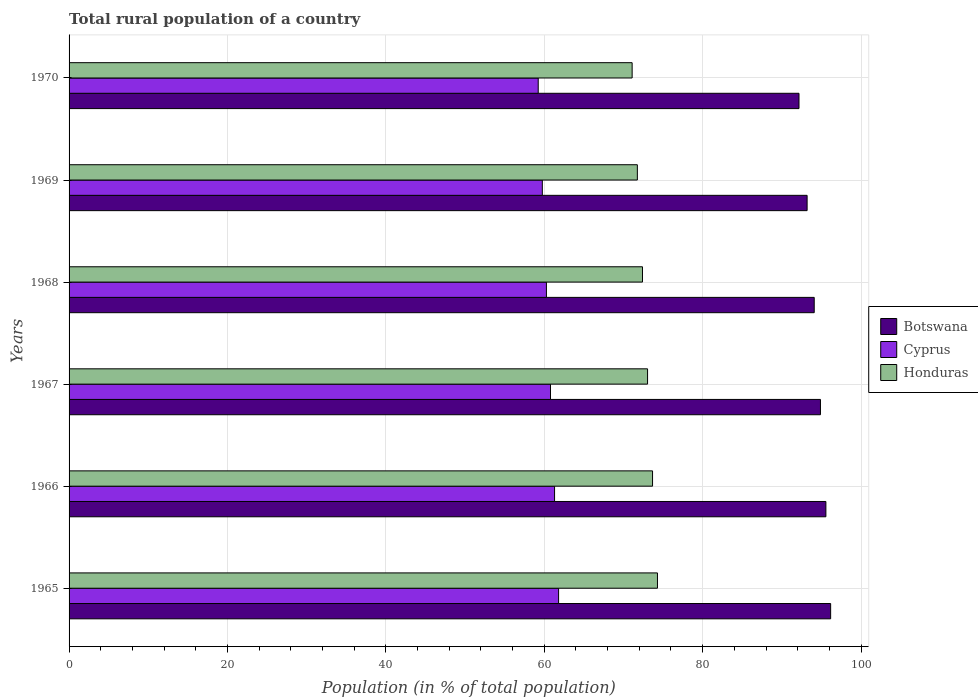How many different coloured bars are there?
Ensure brevity in your answer.  3. Are the number of bars per tick equal to the number of legend labels?
Keep it short and to the point. Yes. Are the number of bars on each tick of the Y-axis equal?
Ensure brevity in your answer.  Yes. How many bars are there on the 4th tick from the bottom?
Keep it short and to the point. 3. What is the label of the 2nd group of bars from the top?
Your response must be concise. 1969. What is the rural population in Botswana in 1970?
Your response must be concise. 92.17. Across all years, what is the maximum rural population in Honduras?
Give a very brief answer. 74.3. Across all years, what is the minimum rural population in Botswana?
Provide a short and direct response. 92.17. In which year was the rural population in Botswana maximum?
Offer a terse response. 1965. What is the total rural population in Botswana in the graph?
Your response must be concise. 566.04. What is the difference between the rural population in Cyprus in 1965 and that in 1966?
Your answer should be compact. 0.51. What is the difference between the rural population in Botswana in 1969 and the rural population in Honduras in 1968?
Give a very brief answer. 20.79. What is the average rural population in Honduras per year?
Your response must be concise. 72.71. In the year 1967, what is the difference between the rural population in Honduras and rural population in Cyprus?
Provide a succinct answer. 12.26. In how many years, is the rural population in Honduras greater than 48 %?
Your answer should be compact. 6. What is the ratio of the rural population in Honduras in 1968 to that in 1970?
Make the answer very short. 1.02. Is the rural population in Cyprus in 1966 less than that in 1969?
Ensure brevity in your answer.  No. Is the difference between the rural population in Honduras in 1965 and 1966 greater than the difference between the rural population in Cyprus in 1965 and 1966?
Make the answer very short. Yes. What is the difference between the highest and the second highest rural population in Cyprus?
Ensure brevity in your answer.  0.51. What is the difference between the highest and the lowest rural population in Botswana?
Your answer should be very brief. 4. Is the sum of the rural population in Botswana in 1965 and 1966 greater than the maximum rural population in Cyprus across all years?
Make the answer very short. Yes. What does the 2nd bar from the top in 1965 represents?
Your response must be concise. Cyprus. What does the 3rd bar from the bottom in 1969 represents?
Keep it short and to the point. Honduras. Is it the case that in every year, the sum of the rural population in Botswana and rural population in Honduras is greater than the rural population in Cyprus?
Make the answer very short. Yes. Are all the bars in the graph horizontal?
Make the answer very short. Yes. How many years are there in the graph?
Make the answer very short. 6. Does the graph contain any zero values?
Keep it short and to the point. No. Does the graph contain grids?
Ensure brevity in your answer.  Yes. Where does the legend appear in the graph?
Offer a very short reply. Center right. How many legend labels are there?
Provide a short and direct response. 3. How are the legend labels stacked?
Provide a short and direct response. Vertical. What is the title of the graph?
Offer a very short reply. Total rural population of a country. Does "French Polynesia" appear as one of the legend labels in the graph?
Make the answer very short. No. What is the label or title of the X-axis?
Offer a very short reply. Population (in % of total population). What is the label or title of the Y-axis?
Your response must be concise. Years. What is the Population (in % of total population) in Botswana in 1965?
Offer a very short reply. 96.16. What is the Population (in % of total population) of Cyprus in 1965?
Provide a short and direct response. 61.81. What is the Population (in % of total population) in Honduras in 1965?
Keep it short and to the point. 74.3. What is the Population (in % of total population) of Botswana in 1966?
Ensure brevity in your answer.  95.56. What is the Population (in % of total population) in Cyprus in 1966?
Your answer should be very brief. 61.3. What is the Population (in % of total population) of Honduras in 1966?
Provide a short and direct response. 73.67. What is the Population (in % of total population) in Botswana in 1967?
Ensure brevity in your answer.  94.88. What is the Population (in % of total population) in Cyprus in 1967?
Keep it short and to the point. 60.79. What is the Population (in % of total population) of Honduras in 1967?
Your answer should be very brief. 73.05. What is the Population (in % of total population) in Botswana in 1968?
Provide a short and direct response. 94.09. What is the Population (in % of total population) of Cyprus in 1968?
Make the answer very short. 60.27. What is the Population (in % of total population) in Honduras in 1968?
Provide a succinct answer. 72.4. What is the Population (in % of total population) in Botswana in 1969?
Offer a very short reply. 93.19. What is the Population (in % of total population) in Cyprus in 1969?
Offer a very short reply. 59.76. What is the Population (in % of total population) of Honduras in 1969?
Give a very brief answer. 71.76. What is the Population (in % of total population) in Botswana in 1970?
Provide a short and direct response. 92.17. What is the Population (in % of total population) of Cyprus in 1970?
Ensure brevity in your answer.  59.24. What is the Population (in % of total population) of Honduras in 1970?
Offer a terse response. 71.1. Across all years, what is the maximum Population (in % of total population) in Botswana?
Keep it short and to the point. 96.16. Across all years, what is the maximum Population (in % of total population) in Cyprus?
Give a very brief answer. 61.81. Across all years, what is the maximum Population (in % of total population) of Honduras?
Provide a short and direct response. 74.3. Across all years, what is the minimum Population (in % of total population) in Botswana?
Make the answer very short. 92.17. Across all years, what is the minimum Population (in % of total population) of Cyprus?
Your answer should be very brief. 59.24. Across all years, what is the minimum Population (in % of total population) in Honduras?
Give a very brief answer. 71.1. What is the total Population (in % of total population) in Botswana in the graph?
Provide a short and direct response. 566.04. What is the total Population (in % of total population) of Cyprus in the graph?
Offer a very short reply. 363.18. What is the total Population (in % of total population) of Honduras in the graph?
Provide a succinct answer. 436.27. What is the difference between the Population (in % of total population) in Botswana in 1965 and that in 1966?
Ensure brevity in your answer.  0.6. What is the difference between the Population (in % of total population) in Cyprus in 1965 and that in 1966?
Your response must be concise. 0.51. What is the difference between the Population (in % of total population) in Honduras in 1965 and that in 1966?
Ensure brevity in your answer.  0.62. What is the difference between the Population (in % of total population) in Botswana in 1965 and that in 1967?
Offer a terse response. 1.28. What is the difference between the Population (in % of total population) of Honduras in 1965 and that in 1967?
Provide a short and direct response. 1.25. What is the difference between the Population (in % of total population) of Botswana in 1965 and that in 1968?
Keep it short and to the point. 2.07. What is the difference between the Population (in % of total population) of Cyprus in 1965 and that in 1968?
Offer a very short reply. 1.54. What is the difference between the Population (in % of total population) in Honduras in 1965 and that in 1968?
Your response must be concise. 1.89. What is the difference between the Population (in % of total population) of Botswana in 1965 and that in 1969?
Provide a succinct answer. 2.97. What is the difference between the Population (in % of total population) of Cyprus in 1965 and that in 1969?
Your response must be concise. 2.05. What is the difference between the Population (in % of total population) in Honduras in 1965 and that in 1969?
Keep it short and to the point. 2.54. What is the difference between the Population (in % of total population) in Botswana in 1965 and that in 1970?
Ensure brevity in your answer.  4. What is the difference between the Population (in % of total population) in Cyprus in 1965 and that in 1970?
Your answer should be very brief. 2.57. What is the difference between the Population (in % of total population) of Honduras in 1965 and that in 1970?
Offer a very short reply. 3.2. What is the difference between the Population (in % of total population) in Botswana in 1966 and that in 1967?
Keep it short and to the point. 0.69. What is the difference between the Population (in % of total population) of Cyprus in 1966 and that in 1967?
Offer a very short reply. 0.51. What is the difference between the Population (in % of total population) of Honduras in 1966 and that in 1967?
Keep it short and to the point. 0.63. What is the difference between the Population (in % of total population) of Botswana in 1966 and that in 1968?
Offer a terse response. 1.48. What is the difference between the Population (in % of total population) in Cyprus in 1966 and that in 1968?
Provide a short and direct response. 1.03. What is the difference between the Population (in % of total population) in Honduras in 1966 and that in 1968?
Your answer should be compact. 1.27. What is the difference between the Population (in % of total population) in Botswana in 1966 and that in 1969?
Your response must be concise. 2.37. What is the difference between the Population (in % of total population) of Cyprus in 1966 and that in 1969?
Offer a very short reply. 1.54. What is the difference between the Population (in % of total population) of Honduras in 1966 and that in 1969?
Your answer should be compact. 1.92. What is the difference between the Population (in % of total population) of Botswana in 1966 and that in 1970?
Provide a succinct answer. 3.4. What is the difference between the Population (in % of total population) of Cyprus in 1966 and that in 1970?
Make the answer very short. 2.06. What is the difference between the Population (in % of total population) in Honduras in 1966 and that in 1970?
Your answer should be compact. 2.58. What is the difference between the Population (in % of total population) of Botswana in 1967 and that in 1968?
Ensure brevity in your answer.  0.79. What is the difference between the Population (in % of total population) of Cyprus in 1967 and that in 1968?
Ensure brevity in your answer.  0.52. What is the difference between the Population (in % of total population) of Honduras in 1967 and that in 1968?
Provide a succinct answer. 0.64. What is the difference between the Population (in % of total population) of Botswana in 1967 and that in 1969?
Offer a terse response. 1.69. What is the difference between the Population (in % of total population) in Cyprus in 1967 and that in 1969?
Provide a short and direct response. 1.03. What is the difference between the Population (in % of total population) of Honduras in 1967 and that in 1969?
Ensure brevity in your answer.  1.29. What is the difference between the Population (in % of total population) in Botswana in 1967 and that in 1970?
Your answer should be compact. 2.71. What is the difference between the Population (in % of total population) of Cyprus in 1967 and that in 1970?
Offer a very short reply. 1.55. What is the difference between the Population (in % of total population) of Honduras in 1967 and that in 1970?
Your answer should be very brief. 1.95. What is the difference between the Population (in % of total population) of Botswana in 1968 and that in 1969?
Offer a terse response. 0.9. What is the difference between the Population (in % of total population) in Cyprus in 1968 and that in 1969?
Offer a very short reply. 0.52. What is the difference between the Population (in % of total population) in Honduras in 1968 and that in 1969?
Give a very brief answer. 0.65. What is the difference between the Population (in % of total population) of Botswana in 1968 and that in 1970?
Your response must be concise. 1.92. What is the difference between the Population (in % of total population) of Cyprus in 1968 and that in 1970?
Keep it short and to the point. 1.03. What is the difference between the Population (in % of total population) in Honduras in 1968 and that in 1970?
Make the answer very short. 1.31. What is the difference between the Population (in % of total population) in Botswana in 1969 and that in 1970?
Provide a succinct answer. 1.02. What is the difference between the Population (in % of total population) in Cyprus in 1969 and that in 1970?
Offer a very short reply. 0.52. What is the difference between the Population (in % of total population) of Honduras in 1969 and that in 1970?
Keep it short and to the point. 0.66. What is the difference between the Population (in % of total population) of Botswana in 1965 and the Population (in % of total population) of Cyprus in 1966?
Give a very brief answer. 34.86. What is the difference between the Population (in % of total population) in Botswana in 1965 and the Population (in % of total population) in Honduras in 1966?
Provide a succinct answer. 22.49. What is the difference between the Population (in % of total population) in Cyprus in 1965 and the Population (in % of total population) in Honduras in 1966?
Provide a short and direct response. -11.86. What is the difference between the Population (in % of total population) of Botswana in 1965 and the Population (in % of total population) of Cyprus in 1967?
Provide a succinct answer. 35.37. What is the difference between the Population (in % of total population) of Botswana in 1965 and the Population (in % of total population) of Honduras in 1967?
Offer a terse response. 23.12. What is the difference between the Population (in % of total population) of Cyprus in 1965 and the Population (in % of total population) of Honduras in 1967?
Make the answer very short. -11.23. What is the difference between the Population (in % of total population) in Botswana in 1965 and the Population (in % of total population) in Cyprus in 1968?
Offer a terse response. 35.89. What is the difference between the Population (in % of total population) of Botswana in 1965 and the Population (in % of total population) of Honduras in 1968?
Keep it short and to the point. 23.76. What is the difference between the Population (in % of total population) in Cyprus in 1965 and the Population (in % of total population) in Honduras in 1968?
Give a very brief answer. -10.59. What is the difference between the Population (in % of total population) in Botswana in 1965 and the Population (in % of total population) in Cyprus in 1969?
Give a very brief answer. 36.4. What is the difference between the Population (in % of total population) in Botswana in 1965 and the Population (in % of total population) in Honduras in 1969?
Keep it short and to the point. 24.41. What is the difference between the Population (in % of total population) of Cyprus in 1965 and the Population (in % of total population) of Honduras in 1969?
Give a very brief answer. -9.94. What is the difference between the Population (in % of total population) in Botswana in 1965 and the Population (in % of total population) in Cyprus in 1970?
Offer a terse response. 36.92. What is the difference between the Population (in % of total population) of Botswana in 1965 and the Population (in % of total population) of Honduras in 1970?
Make the answer very short. 25.06. What is the difference between the Population (in % of total population) of Cyprus in 1965 and the Population (in % of total population) of Honduras in 1970?
Offer a very short reply. -9.29. What is the difference between the Population (in % of total population) in Botswana in 1966 and the Population (in % of total population) in Cyprus in 1967?
Provide a short and direct response. 34.77. What is the difference between the Population (in % of total population) in Botswana in 1966 and the Population (in % of total population) in Honduras in 1967?
Provide a succinct answer. 22.52. What is the difference between the Population (in % of total population) of Cyprus in 1966 and the Population (in % of total population) of Honduras in 1967?
Give a very brief answer. -11.74. What is the difference between the Population (in % of total population) in Botswana in 1966 and the Population (in % of total population) in Cyprus in 1968?
Offer a terse response. 35.29. What is the difference between the Population (in % of total population) in Botswana in 1966 and the Population (in % of total population) in Honduras in 1968?
Give a very brief answer. 23.16. What is the difference between the Population (in % of total population) of Cyprus in 1966 and the Population (in % of total population) of Honduras in 1968?
Provide a short and direct response. -11.1. What is the difference between the Population (in % of total population) of Botswana in 1966 and the Population (in % of total population) of Cyprus in 1969?
Offer a very short reply. 35.8. What is the difference between the Population (in % of total population) of Botswana in 1966 and the Population (in % of total population) of Honduras in 1969?
Your answer should be compact. 23.81. What is the difference between the Population (in % of total population) in Cyprus in 1966 and the Population (in % of total population) in Honduras in 1969?
Provide a succinct answer. -10.45. What is the difference between the Population (in % of total population) of Botswana in 1966 and the Population (in % of total population) of Cyprus in 1970?
Ensure brevity in your answer.  36.32. What is the difference between the Population (in % of total population) in Botswana in 1966 and the Population (in % of total population) in Honduras in 1970?
Ensure brevity in your answer.  24.46. What is the difference between the Population (in % of total population) in Cyprus in 1966 and the Population (in % of total population) in Honduras in 1970?
Your response must be concise. -9.8. What is the difference between the Population (in % of total population) of Botswana in 1967 and the Population (in % of total population) of Cyprus in 1968?
Provide a succinct answer. 34.6. What is the difference between the Population (in % of total population) of Botswana in 1967 and the Population (in % of total population) of Honduras in 1968?
Your answer should be compact. 22.47. What is the difference between the Population (in % of total population) of Cyprus in 1967 and the Population (in % of total population) of Honduras in 1968?
Offer a terse response. -11.61. What is the difference between the Population (in % of total population) in Botswana in 1967 and the Population (in % of total population) in Cyprus in 1969?
Offer a very short reply. 35.12. What is the difference between the Population (in % of total population) in Botswana in 1967 and the Population (in % of total population) in Honduras in 1969?
Ensure brevity in your answer.  23.12. What is the difference between the Population (in % of total population) in Cyprus in 1967 and the Population (in % of total population) in Honduras in 1969?
Make the answer very short. -10.97. What is the difference between the Population (in % of total population) in Botswana in 1967 and the Population (in % of total population) in Cyprus in 1970?
Keep it short and to the point. 35.64. What is the difference between the Population (in % of total population) in Botswana in 1967 and the Population (in % of total population) in Honduras in 1970?
Offer a very short reply. 23.78. What is the difference between the Population (in % of total population) of Cyprus in 1967 and the Population (in % of total population) of Honduras in 1970?
Make the answer very short. -10.31. What is the difference between the Population (in % of total population) in Botswana in 1968 and the Population (in % of total population) in Cyprus in 1969?
Provide a short and direct response. 34.33. What is the difference between the Population (in % of total population) in Botswana in 1968 and the Population (in % of total population) in Honduras in 1969?
Keep it short and to the point. 22.33. What is the difference between the Population (in % of total population) in Cyprus in 1968 and the Population (in % of total population) in Honduras in 1969?
Give a very brief answer. -11.48. What is the difference between the Population (in % of total population) of Botswana in 1968 and the Population (in % of total population) of Cyprus in 1970?
Ensure brevity in your answer.  34.85. What is the difference between the Population (in % of total population) in Botswana in 1968 and the Population (in % of total population) in Honduras in 1970?
Ensure brevity in your answer.  22.99. What is the difference between the Population (in % of total population) of Cyprus in 1968 and the Population (in % of total population) of Honduras in 1970?
Make the answer very short. -10.82. What is the difference between the Population (in % of total population) of Botswana in 1969 and the Population (in % of total population) of Cyprus in 1970?
Offer a very short reply. 33.95. What is the difference between the Population (in % of total population) of Botswana in 1969 and the Population (in % of total population) of Honduras in 1970?
Give a very brief answer. 22.09. What is the difference between the Population (in % of total population) of Cyprus in 1969 and the Population (in % of total population) of Honduras in 1970?
Offer a very short reply. -11.34. What is the average Population (in % of total population) of Botswana per year?
Provide a succinct answer. 94.34. What is the average Population (in % of total population) in Cyprus per year?
Offer a very short reply. 60.53. What is the average Population (in % of total population) of Honduras per year?
Your response must be concise. 72.71. In the year 1965, what is the difference between the Population (in % of total population) in Botswana and Population (in % of total population) in Cyprus?
Offer a very short reply. 34.35. In the year 1965, what is the difference between the Population (in % of total population) in Botswana and Population (in % of total population) in Honduras?
Provide a short and direct response. 21.86. In the year 1965, what is the difference between the Population (in % of total population) in Cyprus and Population (in % of total population) in Honduras?
Make the answer very short. -12.48. In the year 1966, what is the difference between the Population (in % of total population) of Botswana and Population (in % of total population) of Cyprus?
Your response must be concise. 34.26. In the year 1966, what is the difference between the Population (in % of total population) of Botswana and Population (in % of total population) of Honduras?
Give a very brief answer. 21.89. In the year 1966, what is the difference between the Population (in % of total population) of Cyprus and Population (in % of total population) of Honduras?
Your answer should be very brief. -12.37. In the year 1967, what is the difference between the Population (in % of total population) in Botswana and Population (in % of total population) in Cyprus?
Make the answer very short. 34.09. In the year 1967, what is the difference between the Population (in % of total population) of Botswana and Population (in % of total population) of Honduras?
Give a very brief answer. 21.83. In the year 1967, what is the difference between the Population (in % of total population) of Cyprus and Population (in % of total population) of Honduras?
Keep it short and to the point. -12.26. In the year 1968, what is the difference between the Population (in % of total population) in Botswana and Population (in % of total population) in Cyprus?
Your answer should be very brief. 33.81. In the year 1968, what is the difference between the Population (in % of total population) in Botswana and Population (in % of total population) in Honduras?
Provide a succinct answer. 21.68. In the year 1968, what is the difference between the Population (in % of total population) of Cyprus and Population (in % of total population) of Honduras?
Your response must be concise. -12.13. In the year 1969, what is the difference between the Population (in % of total population) in Botswana and Population (in % of total population) in Cyprus?
Provide a succinct answer. 33.43. In the year 1969, what is the difference between the Population (in % of total population) of Botswana and Population (in % of total population) of Honduras?
Keep it short and to the point. 21.43. In the year 1969, what is the difference between the Population (in % of total population) of Cyprus and Population (in % of total population) of Honduras?
Your response must be concise. -12. In the year 1970, what is the difference between the Population (in % of total population) of Botswana and Population (in % of total population) of Cyprus?
Your answer should be very brief. 32.93. In the year 1970, what is the difference between the Population (in % of total population) in Botswana and Population (in % of total population) in Honduras?
Provide a short and direct response. 21.07. In the year 1970, what is the difference between the Population (in % of total population) in Cyprus and Population (in % of total population) in Honduras?
Offer a terse response. -11.86. What is the ratio of the Population (in % of total population) of Botswana in 1965 to that in 1966?
Provide a short and direct response. 1.01. What is the ratio of the Population (in % of total population) in Cyprus in 1965 to that in 1966?
Offer a very short reply. 1.01. What is the ratio of the Population (in % of total population) of Honduras in 1965 to that in 1966?
Your response must be concise. 1.01. What is the ratio of the Population (in % of total population) in Botswana in 1965 to that in 1967?
Provide a short and direct response. 1.01. What is the ratio of the Population (in % of total population) of Cyprus in 1965 to that in 1967?
Make the answer very short. 1.02. What is the ratio of the Population (in % of total population) of Honduras in 1965 to that in 1967?
Your response must be concise. 1.02. What is the ratio of the Population (in % of total population) of Cyprus in 1965 to that in 1968?
Your response must be concise. 1.03. What is the ratio of the Population (in % of total population) in Honduras in 1965 to that in 1968?
Your answer should be very brief. 1.03. What is the ratio of the Population (in % of total population) in Botswana in 1965 to that in 1969?
Provide a short and direct response. 1.03. What is the ratio of the Population (in % of total population) of Cyprus in 1965 to that in 1969?
Provide a succinct answer. 1.03. What is the ratio of the Population (in % of total population) of Honduras in 1965 to that in 1969?
Your answer should be compact. 1.04. What is the ratio of the Population (in % of total population) of Botswana in 1965 to that in 1970?
Offer a terse response. 1.04. What is the ratio of the Population (in % of total population) of Cyprus in 1965 to that in 1970?
Ensure brevity in your answer.  1.04. What is the ratio of the Population (in % of total population) in Honduras in 1965 to that in 1970?
Your response must be concise. 1.04. What is the ratio of the Population (in % of total population) of Cyprus in 1966 to that in 1967?
Offer a terse response. 1.01. What is the ratio of the Population (in % of total population) in Honduras in 1966 to that in 1967?
Provide a succinct answer. 1.01. What is the ratio of the Population (in % of total population) in Botswana in 1966 to that in 1968?
Your answer should be compact. 1.02. What is the ratio of the Population (in % of total population) in Cyprus in 1966 to that in 1968?
Provide a succinct answer. 1.02. What is the ratio of the Population (in % of total population) in Honduras in 1966 to that in 1968?
Offer a very short reply. 1.02. What is the ratio of the Population (in % of total population) of Botswana in 1966 to that in 1969?
Provide a short and direct response. 1.03. What is the ratio of the Population (in % of total population) in Cyprus in 1966 to that in 1969?
Give a very brief answer. 1.03. What is the ratio of the Population (in % of total population) of Honduras in 1966 to that in 1969?
Offer a terse response. 1.03. What is the ratio of the Population (in % of total population) in Botswana in 1966 to that in 1970?
Offer a very short reply. 1.04. What is the ratio of the Population (in % of total population) of Cyprus in 1966 to that in 1970?
Provide a short and direct response. 1.03. What is the ratio of the Population (in % of total population) in Honduras in 1966 to that in 1970?
Offer a very short reply. 1.04. What is the ratio of the Population (in % of total population) of Botswana in 1967 to that in 1968?
Your response must be concise. 1.01. What is the ratio of the Population (in % of total population) of Cyprus in 1967 to that in 1968?
Keep it short and to the point. 1.01. What is the ratio of the Population (in % of total population) of Honduras in 1967 to that in 1968?
Your answer should be compact. 1.01. What is the ratio of the Population (in % of total population) in Botswana in 1967 to that in 1969?
Ensure brevity in your answer.  1.02. What is the ratio of the Population (in % of total population) in Cyprus in 1967 to that in 1969?
Offer a terse response. 1.02. What is the ratio of the Population (in % of total population) of Botswana in 1967 to that in 1970?
Keep it short and to the point. 1.03. What is the ratio of the Population (in % of total population) in Cyprus in 1967 to that in 1970?
Make the answer very short. 1.03. What is the ratio of the Population (in % of total population) in Honduras in 1967 to that in 1970?
Provide a short and direct response. 1.03. What is the ratio of the Population (in % of total population) in Botswana in 1968 to that in 1969?
Give a very brief answer. 1.01. What is the ratio of the Population (in % of total population) of Cyprus in 1968 to that in 1969?
Ensure brevity in your answer.  1.01. What is the ratio of the Population (in % of total population) in Botswana in 1968 to that in 1970?
Make the answer very short. 1.02. What is the ratio of the Population (in % of total population) of Cyprus in 1968 to that in 1970?
Make the answer very short. 1.02. What is the ratio of the Population (in % of total population) in Honduras in 1968 to that in 1970?
Give a very brief answer. 1.02. What is the ratio of the Population (in % of total population) of Botswana in 1969 to that in 1970?
Your answer should be very brief. 1.01. What is the ratio of the Population (in % of total population) of Cyprus in 1969 to that in 1970?
Provide a short and direct response. 1.01. What is the ratio of the Population (in % of total population) of Honduras in 1969 to that in 1970?
Keep it short and to the point. 1.01. What is the difference between the highest and the second highest Population (in % of total population) of Botswana?
Make the answer very short. 0.6. What is the difference between the highest and the second highest Population (in % of total population) in Cyprus?
Keep it short and to the point. 0.51. What is the difference between the highest and the second highest Population (in % of total population) in Honduras?
Ensure brevity in your answer.  0.62. What is the difference between the highest and the lowest Population (in % of total population) in Botswana?
Offer a terse response. 4. What is the difference between the highest and the lowest Population (in % of total population) of Cyprus?
Offer a very short reply. 2.57. What is the difference between the highest and the lowest Population (in % of total population) of Honduras?
Offer a very short reply. 3.2. 